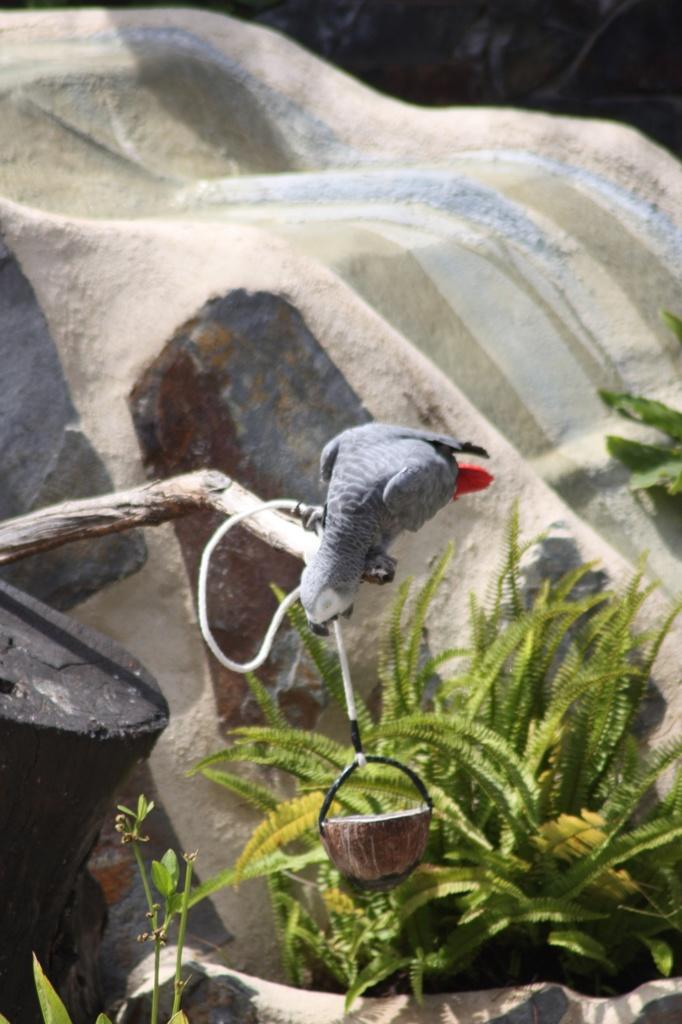What type of animal can be seen in the image? There is a bird in the image. Where is the bird located? The bird is on the branch of a tree. What can be seen in the background of the image? There are plants and a rock in the background of the image. What type of frame is around the bird in the image? There is no frame around the bird in the image; it is a photograph or illustration of the bird in its natural environment. 